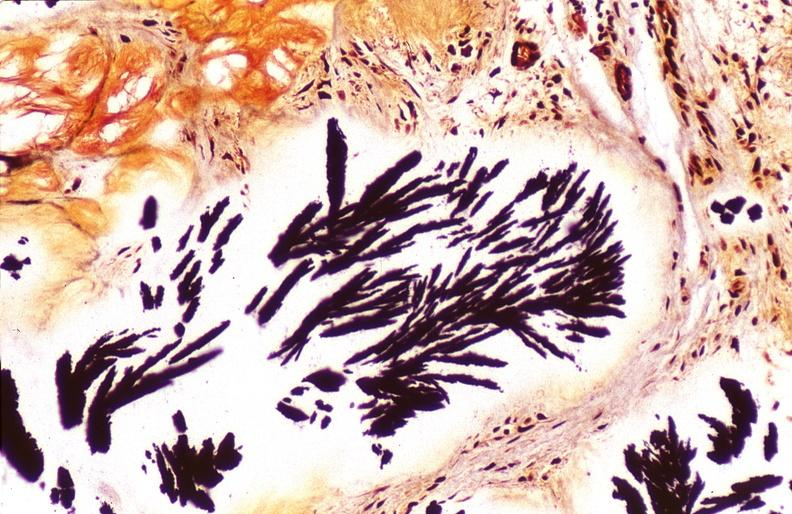what is present?
Answer the question using a single word or phrase. Joints 